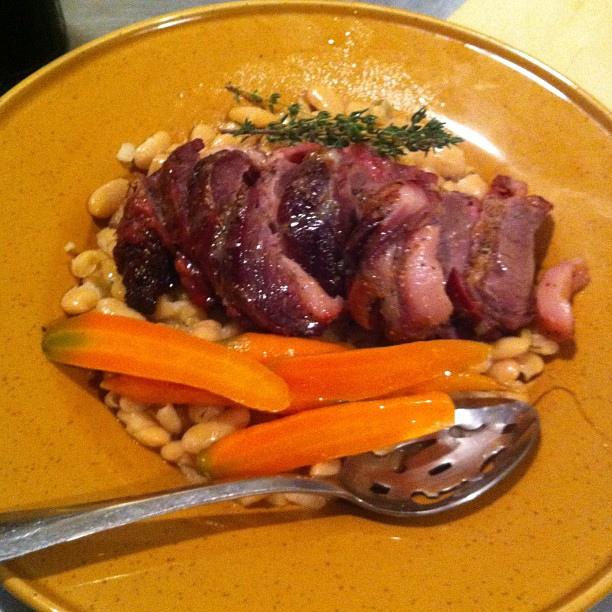What is mainly featured?
Give a very brief answer. Meat. What color is the bowl?
Be succinct. Yellow. What type of food groups are on this photo?
Give a very brief answer. Vegetables, meat, and beans. 